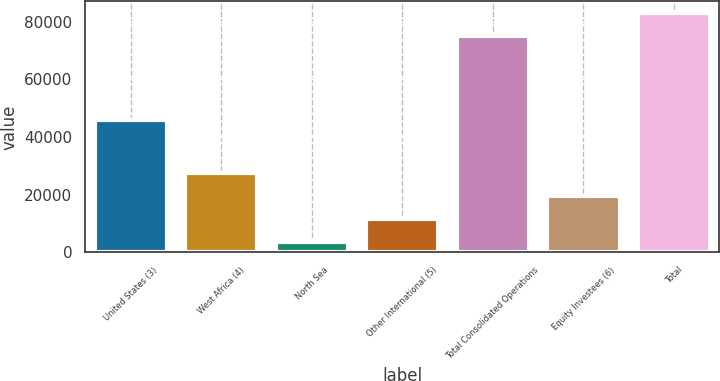<chart> <loc_0><loc_0><loc_500><loc_500><bar_chart><fcel>United States (3)<fcel>West Africa (4)<fcel>North Sea<fcel>Other International (5)<fcel>Total Consolidated Operations<fcel>Equity Investees (6)<fcel>Total<nl><fcel>45798<fcel>27486<fcel>3717<fcel>11640<fcel>74915<fcel>19563<fcel>82947<nl></chart> 